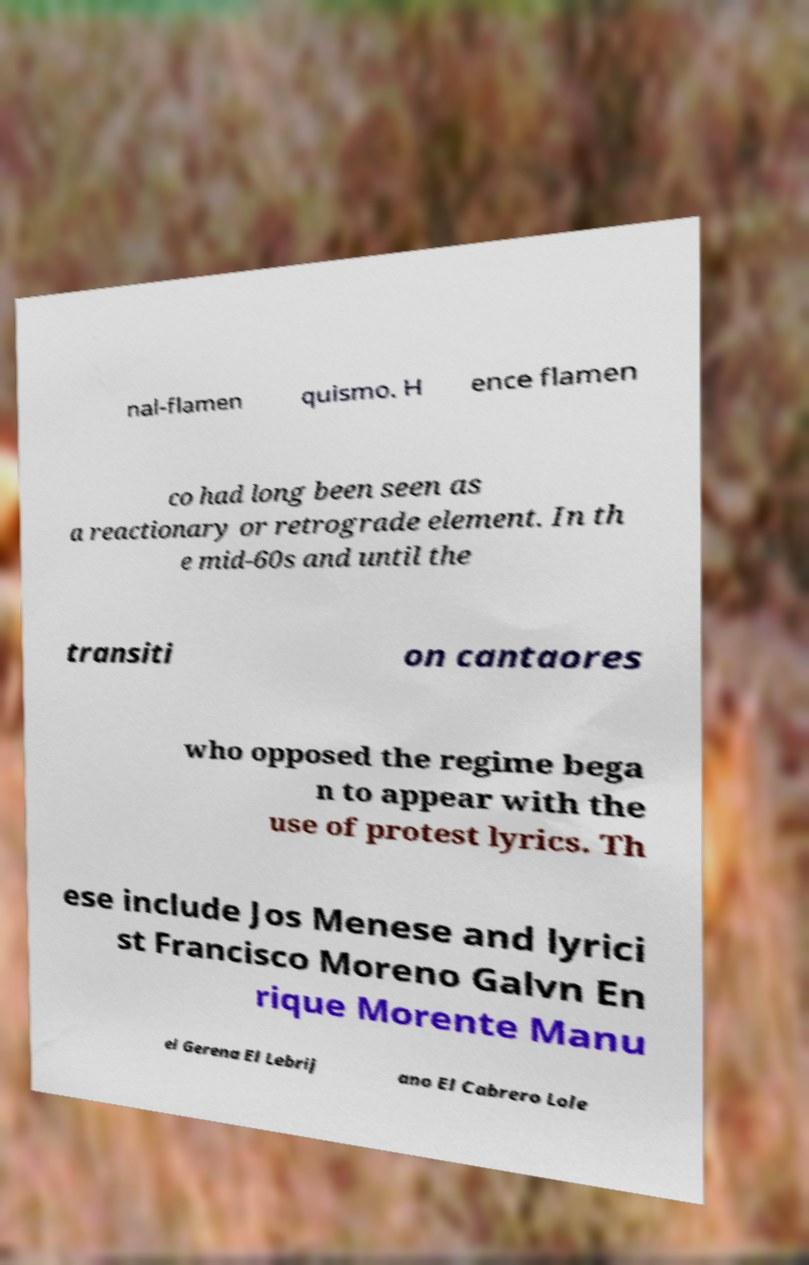I need the written content from this picture converted into text. Can you do that? nal-flamen quismo. H ence flamen co had long been seen as a reactionary or retrograde element. In th e mid-60s and until the transiti on cantaores who opposed the regime bega n to appear with the use of protest lyrics. Th ese include Jos Menese and lyrici st Francisco Moreno Galvn En rique Morente Manu el Gerena El Lebrij ano El Cabrero Lole 